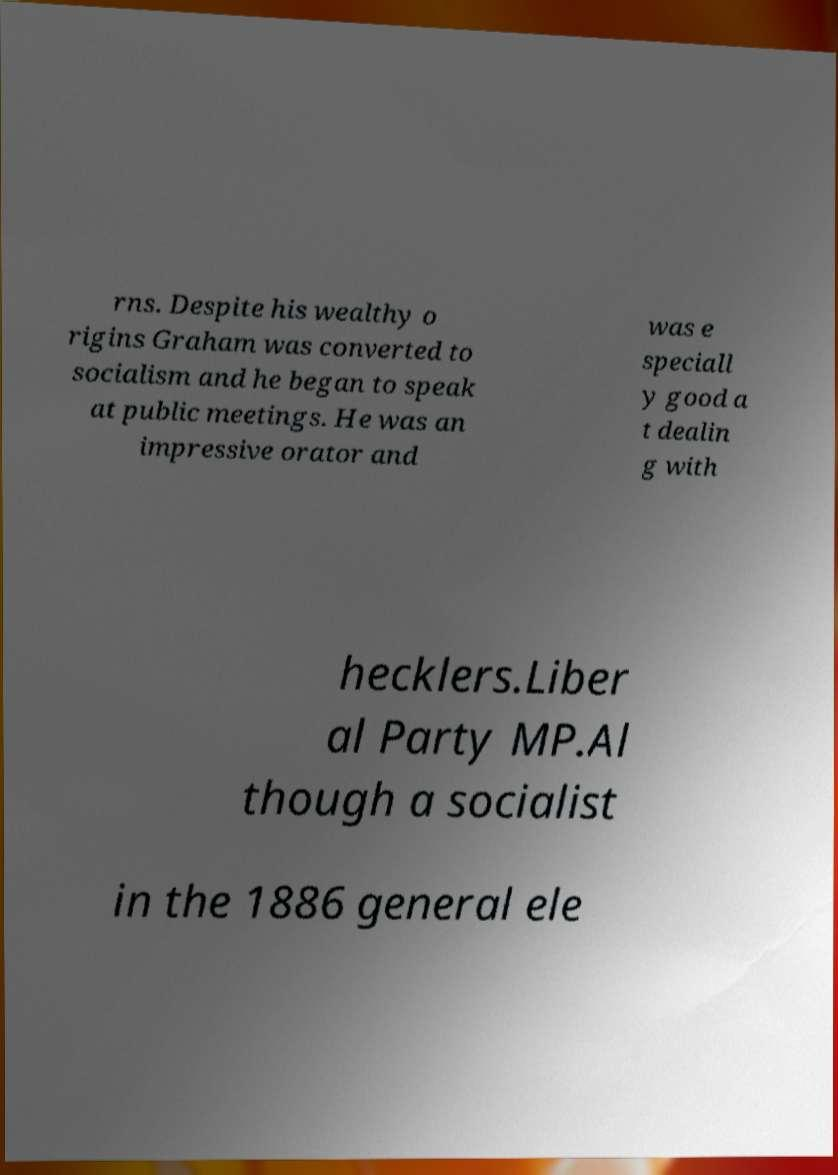Please read and relay the text visible in this image. What does it say? rns. Despite his wealthy o rigins Graham was converted to socialism and he began to speak at public meetings. He was an impressive orator and was e speciall y good a t dealin g with hecklers.Liber al Party MP.Al though a socialist in the 1886 general ele 